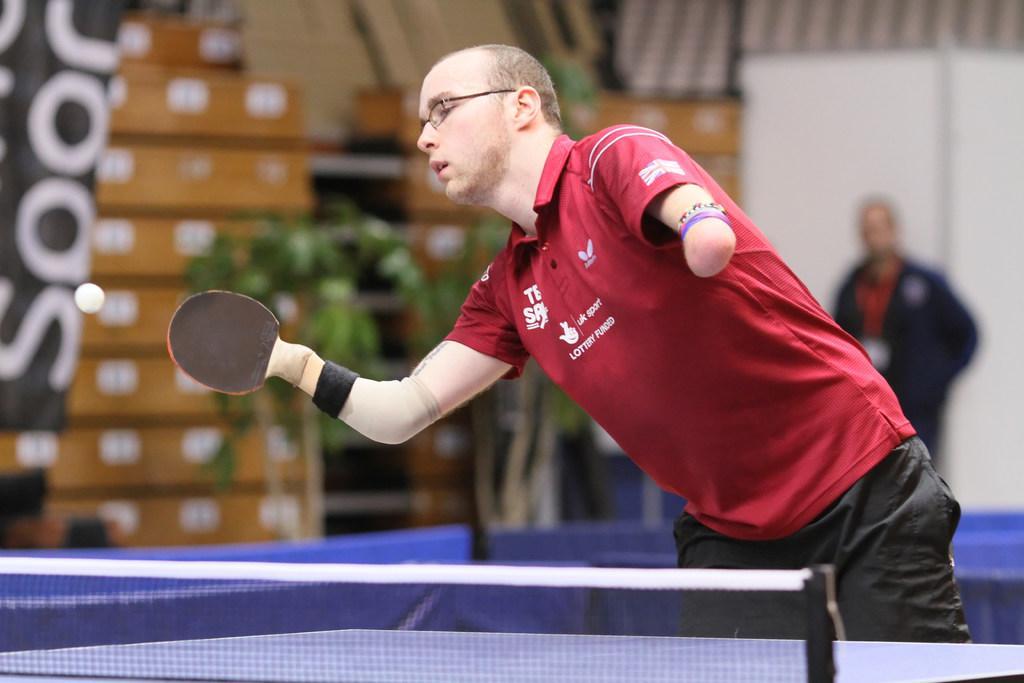How would you summarize this image in a sentence or two? In this image we can see a person standing and holding table tennis bat. In front of him we can see the table tennis and blur background. 